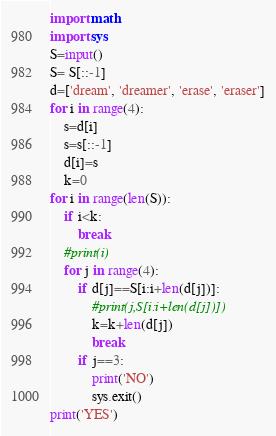<code> <loc_0><loc_0><loc_500><loc_500><_Python_>import math
import sys
S=input()
S= S[::-1]
d=['dream', 'dreamer', 'erase', 'eraser']
for i in range(4):
    s=d[i]
    s=s[::-1]
    d[i]=s
    k=0
for i in range(len(S)):
    if i<k:
        break
    #print(i)
    for j in range(4):
        if d[j]==S[i:i+len(d[j])]:
            #print(j,S[i:i+len(d[j])])
            k=k+len(d[j])
            break
        if j==3:
            print('NO')
            sys.exit()
print('YES')</code> 